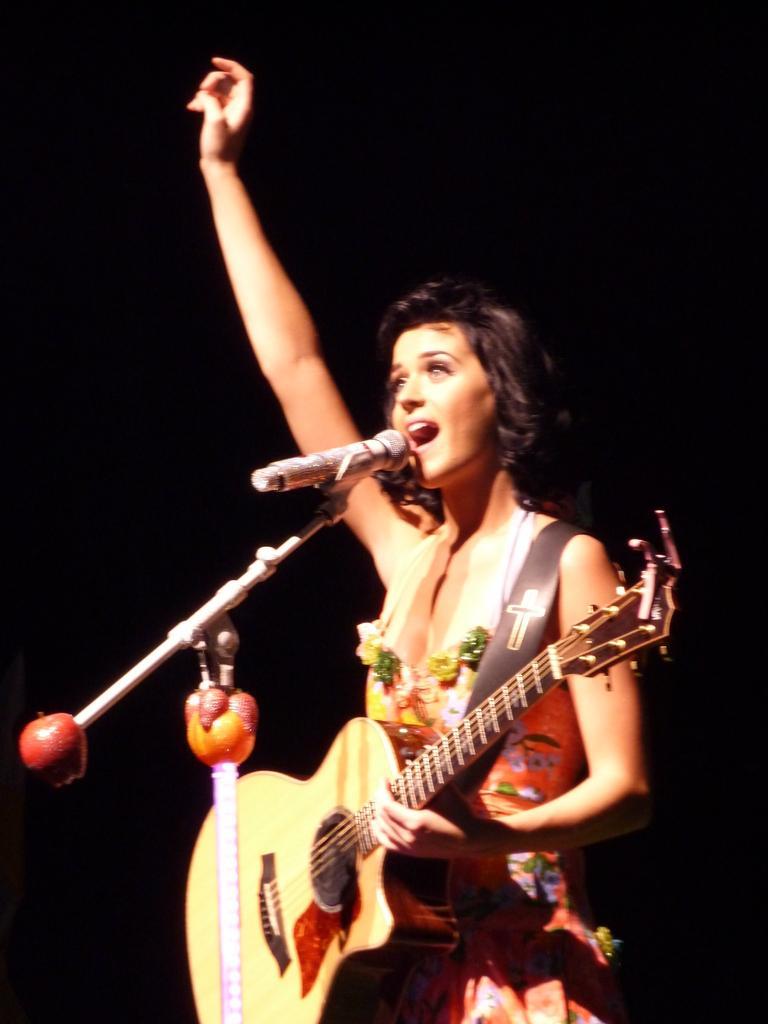Please provide a concise description of this image. In this image there is a lady standing and holding a guitar in her hand. She is singing a song. There is a mic placed before her. 